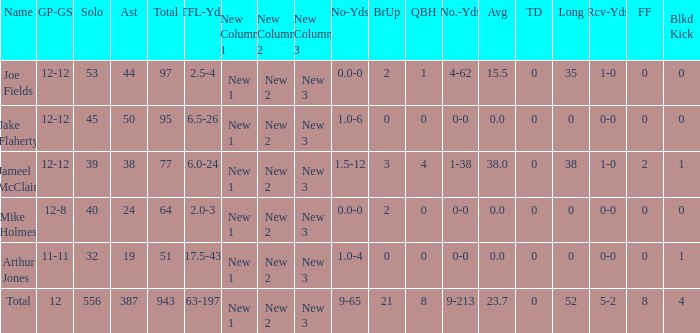How many players named jake flaherty? 1.0. 